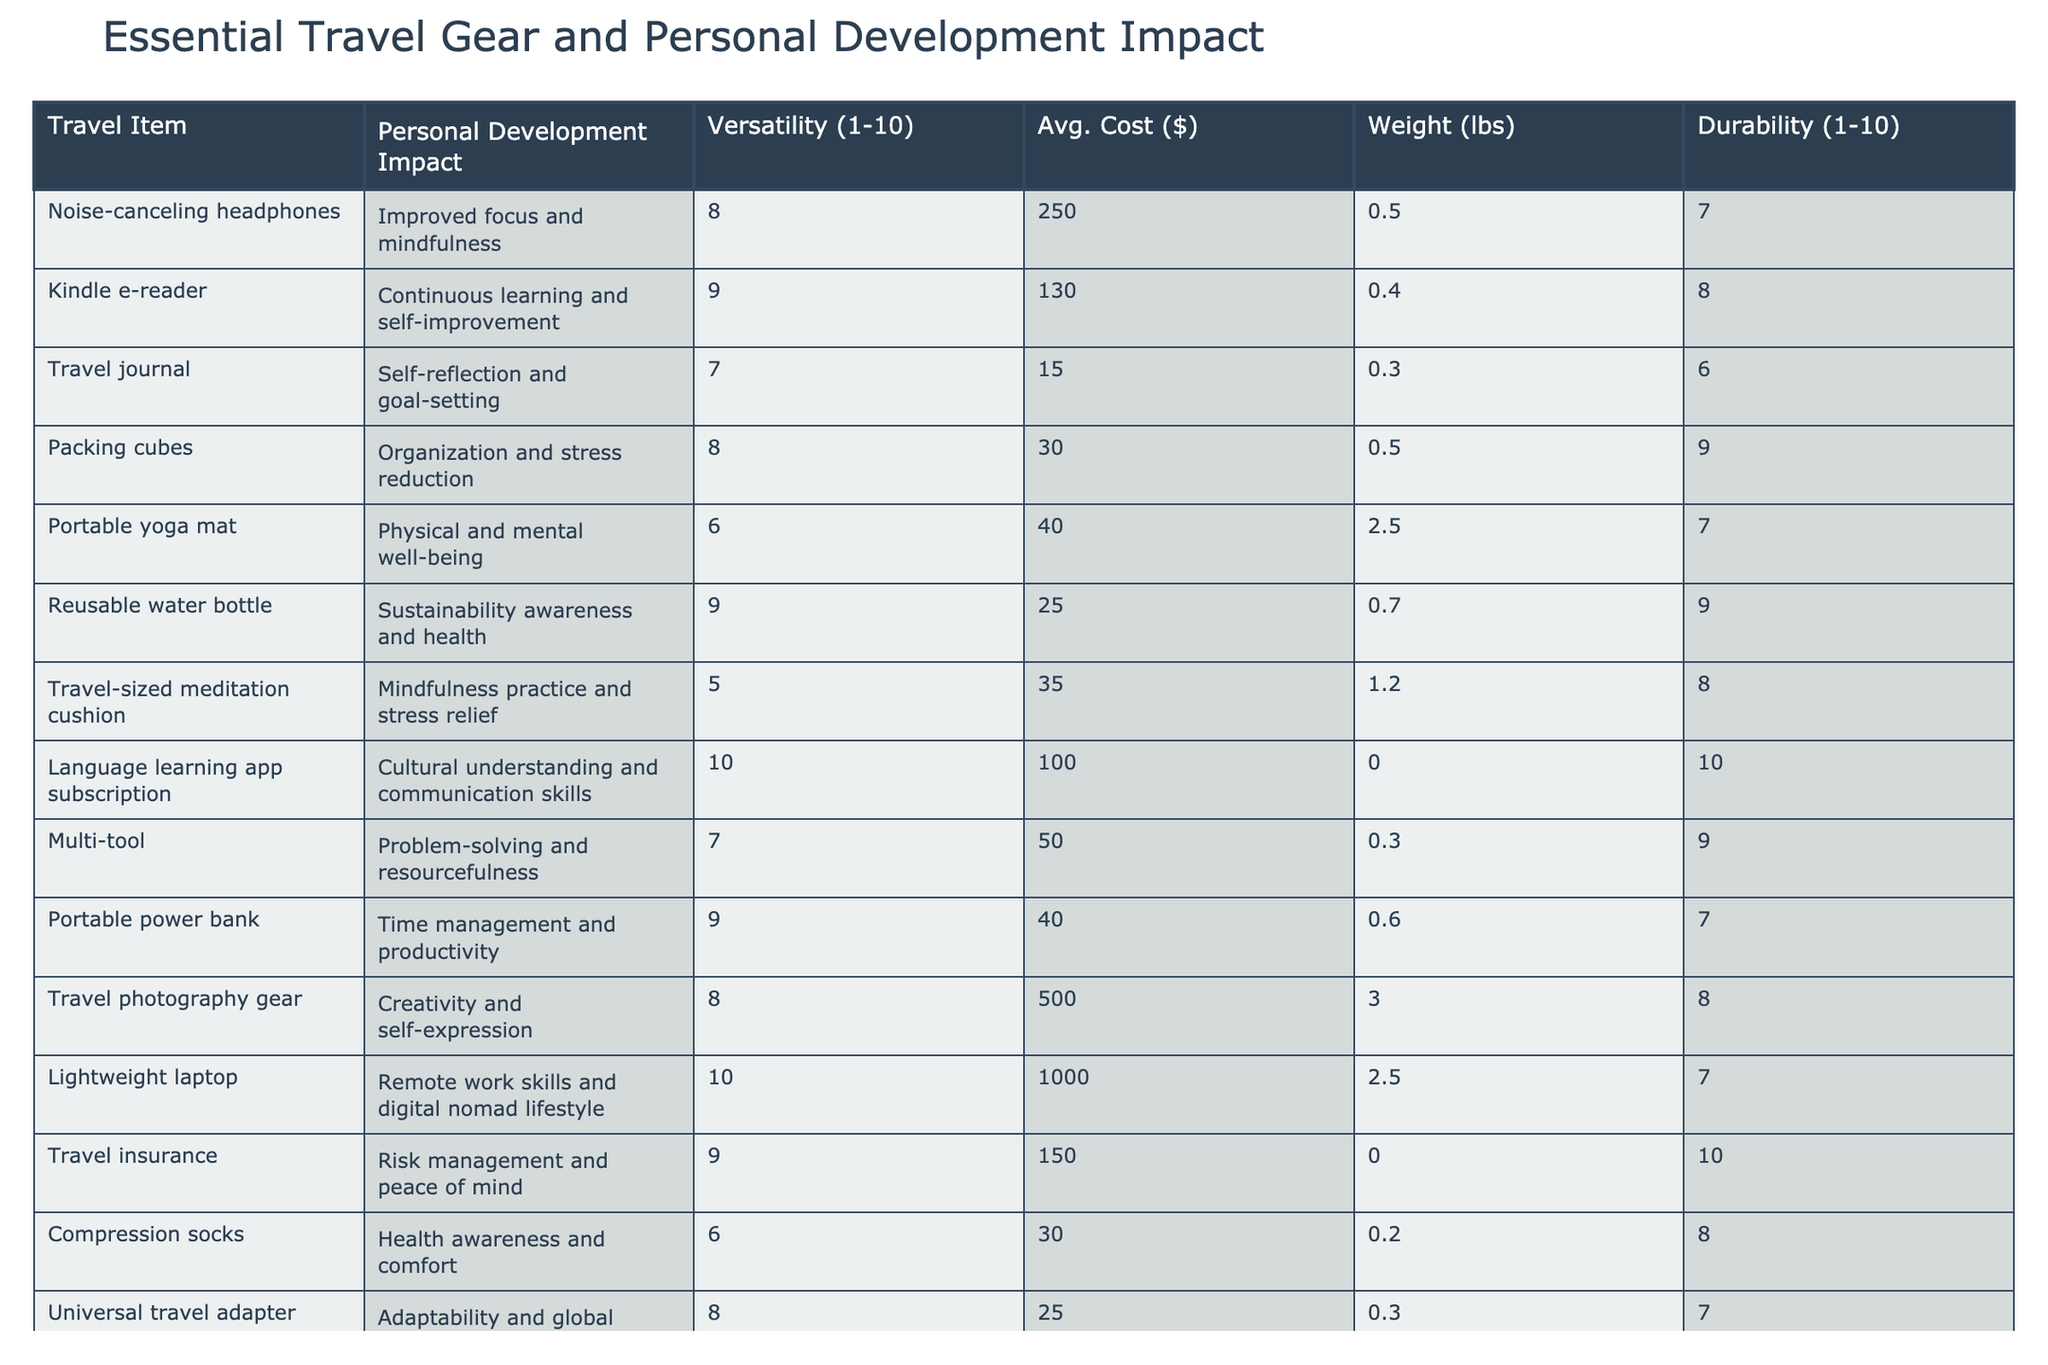What is the versatility score of the reusable water bottle? Referring to the table, the versatility score for the reusable water bottle is specifically listed under the Versatility column. It is shown as 9.
Answer: 9 Which travel item has the highest average cost? By inspecting the Avg. Cost column, the travel photography gear has the highest cost at $500 when compared to all other items.
Answer: $500 Is the travel journal more durable than the portable yoga mat? The durability score for the travel journal is 6, while the portable yoga mat has a durability score of 7. Since 7 is greater than 6, the portable yoga mat is more durable.
Answer: No What is the average weight of items that promote physical and mental well-being? The items promoting physical and mental well-being are the portable yoga mat (2.5 lbs) and travel-sized meditation cushion (1.2 lbs). Their average weight is (2.5 + 1.2) / 2 = 1.85 lbs.
Answer: 1.85 lbs Which travel items contribute to cultural understanding and communication skills? The only travel item listed in the table that contributes to cultural understanding and communication skills is the language learning app subscription, which has a versatility score of 10 and contributes significantly to this area.
Answer: Language learning app subscription What is the difference in versatility scores between the noise-canceling headphones and the travel journal? The versatility score of the noise-canceling headphones is 8, and the travel journal’s score is 7. The difference is 8 - 7 = 1.
Answer: 1 Which item has a lower average cost: compression socks or travel insurance? Checking the Avg. Cost column, compression socks cost $30, and travel insurance costs $150. Since $30 is less than $150, compression socks have a lower average cost.
Answer: Compression socks What is the total weight of the items that have a durability score of 10? In the table, the travel insurance and language learning app subscription both have a durability score of 10, with weights of 0 lbs each. So, the total weight is 0 + 0 = 0 lbs.
Answer: 0 lbs Does a higher versatility score correlate with higher costs for travel gear? To answer this, we can look at multiple rows. Noise-canceling headphones have a versatility score of 8 and cost $250, while the language learning app has a score of 10 and costs $100. This shows that a higher versatility score does not necessarily lead to higher costs, as there are varying costs for varying scores.
Answer: No What item contributes the most to self-reflection and goal-setting in terms of personal development? According to the table, the travel journal explicitly states that it is geared towards self-reflection and goal-setting, making it the most relevant item for this aspect of personal development.
Answer: Travel journal 